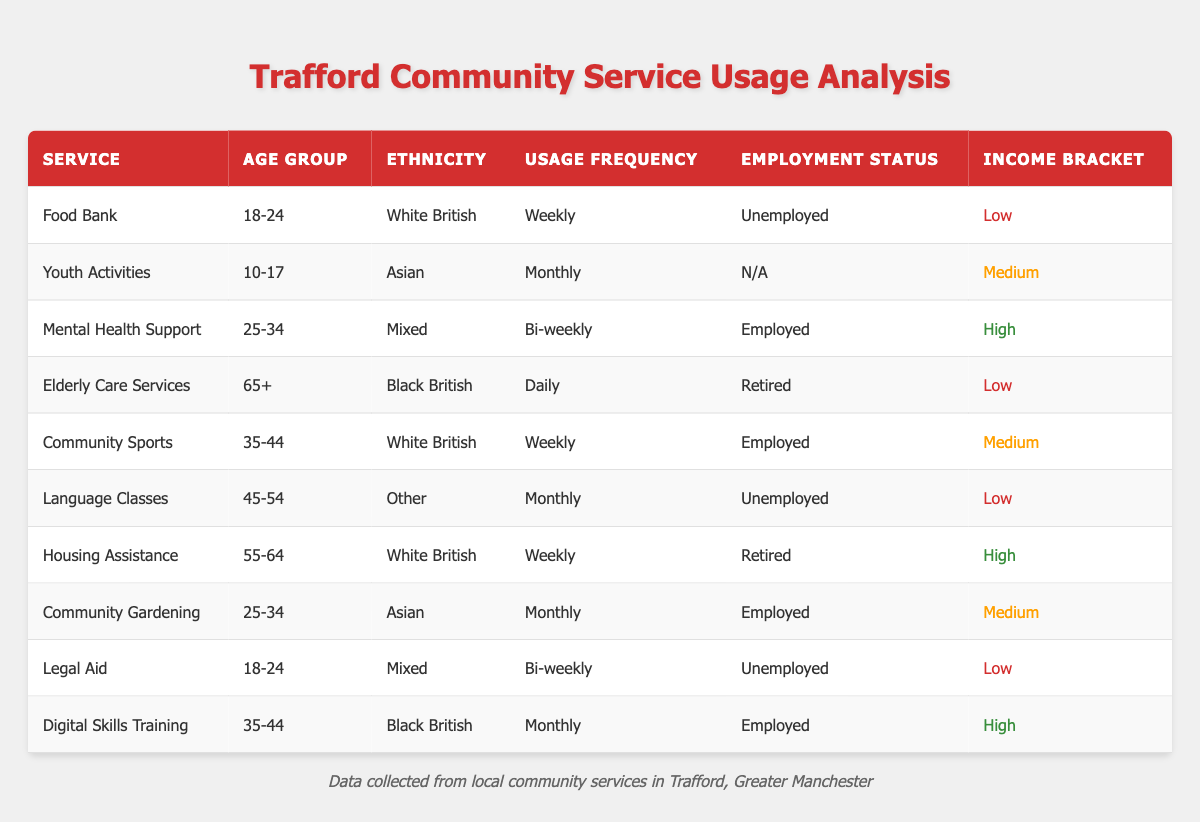What is the usage frequency of the Food Bank service? The table lists the Food Bank service under the "Usage Frequency" column as "Weekly" for the age group 18-24, ethnicity White British, unemployed status, and low income bracket.
Answer: Weekly How many services have a usage frequency of Monthly? There are four services listed with a usage frequency of "Monthly." They are Youth Activities, Language Classes, Community Gardening, and Digital Skills Training.
Answer: Four Is there any service used daily by the elderly? The table contains the "Elderly Care Services" which is categorized under the age group 65+, and its usage frequency is recorded as "Daily." This confirms that there is indeed a service that is used daily by the elderly.
Answer: Yes Which income bracket has the highest frequency of service usage noted in the table? By analyzing the frequency of service usage across income brackets: "Low" is three times weekly (Food Bank, Elderly Care, and Legal Aid), "Medium" has two weekly (Community Sports) and something monthly (Youth Activities, Community Gardening), while "High" has two services of "Monthly." Therefore, the "Low" income bracket has the highest frequency of service usage.
Answer: Low What is the age group with the most employed individuals using community services? The age group 35-44 has two employed individuals using community services (Community Sports and Digital Skills Training), more than any other age group. The breakdown: age group 18-24 has 1 employed, 25-34 has 1 employed, and 45-54 has 0. Hence, 35-44 is the age group with the most employed.
Answer: 35-44 